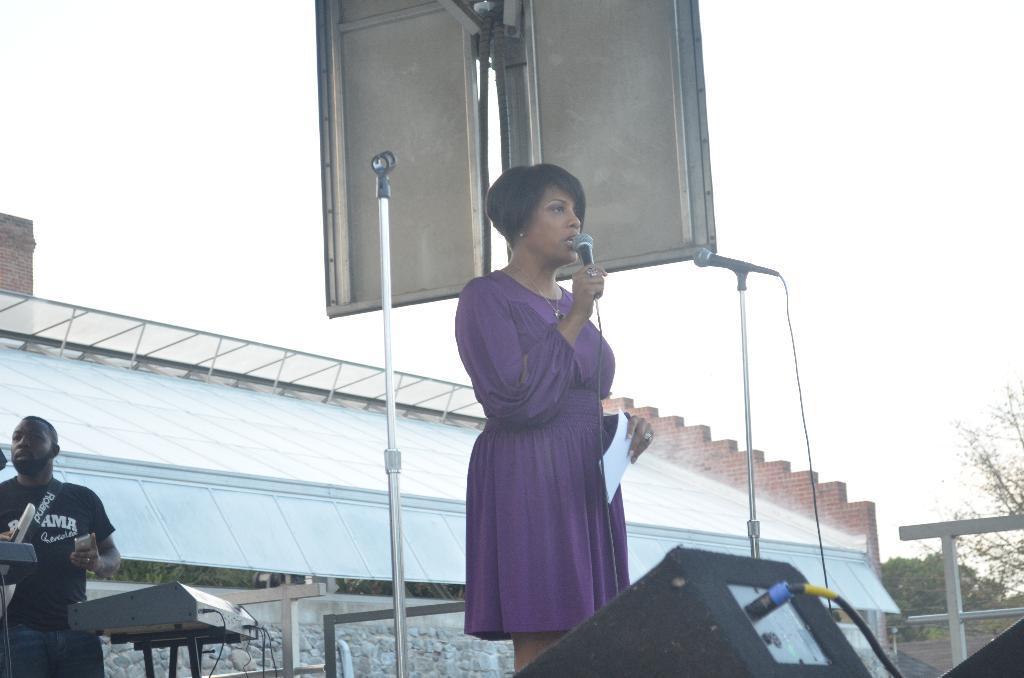How would you summarize this image in a sentence or two? In this image in the front there is an object which is black in colour. In the center there is woman standing and holding a paper and mic in her hand and speaking and there is a stand and there is a mic in front of the woman. In the background there is a person standing and there is an object which is black in colour and there is a wall, there are trees and there is a fence which is white in colour. 